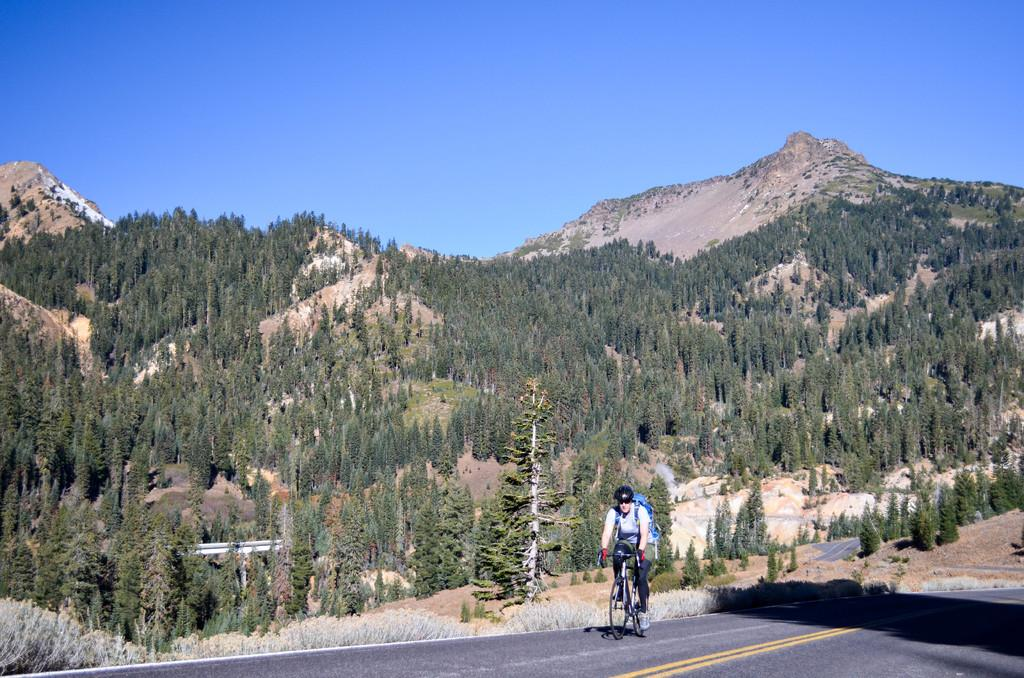What is the person in the image doing? There is a person cycling in the image. Where is the person cycling? The person is on the road. What can be seen in the background of the image? There is a hill in the background of the image, and it is covered with trees. What is visible above the hill? The sky is visible above the hill. What type of gold can be seen on the scale in the image? There is no gold or scale present in the image. What boundary is visible between the hill and the sky in the image? There is no boundary visible between the hill and the sky in the image; they naturally blend together. 